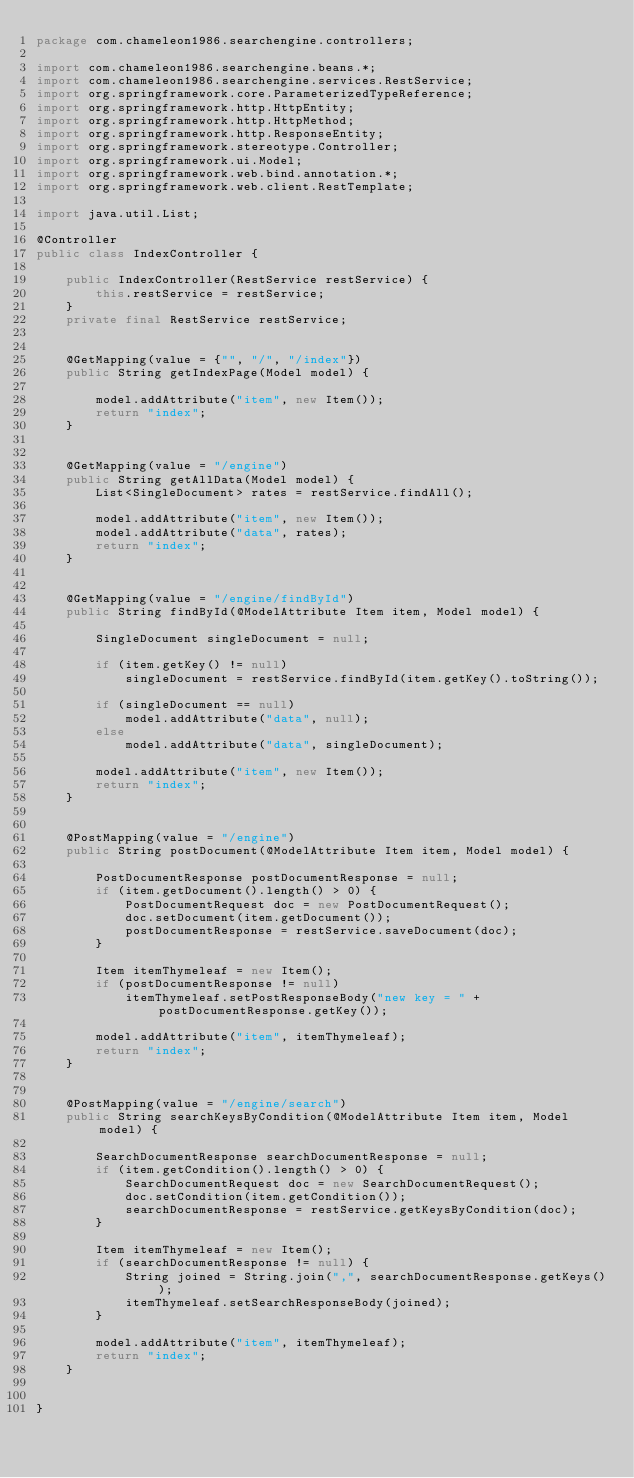<code> <loc_0><loc_0><loc_500><loc_500><_Java_>package com.chameleon1986.searchengine.controllers;

import com.chameleon1986.searchengine.beans.*;
import com.chameleon1986.searchengine.services.RestService;
import org.springframework.core.ParameterizedTypeReference;
import org.springframework.http.HttpEntity;
import org.springframework.http.HttpMethod;
import org.springframework.http.ResponseEntity;
import org.springframework.stereotype.Controller;
import org.springframework.ui.Model;
import org.springframework.web.bind.annotation.*;
import org.springframework.web.client.RestTemplate;

import java.util.List;

@Controller
public class IndexController {

    public IndexController(RestService restService) {
        this.restService = restService;
    }
    private final RestService restService;


    @GetMapping(value = {"", "/", "/index"})
    public String getIndexPage(Model model) {

        model.addAttribute("item", new Item());
        return "index";
    }


    @GetMapping(value = "/engine")
    public String getAllData(Model model) {
        List<SingleDocument> rates = restService.findAll();

        model.addAttribute("item", new Item());
        model.addAttribute("data", rates);
        return "index";
    }


    @GetMapping(value = "/engine/findById")
    public String findById(@ModelAttribute Item item, Model model) {

        SingleDocument singleDocument = null;

        if (item.getKey() != null)
            singleDocument = restService.findById(item.getKey().toString());

        if (singleDocument == null)
            model.addAttribute("data", null);
        else
            model.addAttribute("data", singleDocument);

        model.addAttribute("item", new Item());
        return "index";
    }


    @PostMapping(value = "/engine")
    public String postDocument(@ModelAttribute Item item, Model model) {

        PostDocumentResponse postDocumentResponse = null;
        if (item.getDocument().length() > 0) {
            PostDocumentRequest doc = new PostDocumentRequest();
            doc.setDocument(item.getDocument());
            postDocumentResponse = restService.saveDocument(doc);
        }

        Item itemThymeleaf = new Item();
        if (postDocumentResponse != null)
            itemThymeleaf.setPostResponseBody("new key = " + postDocumentResponse.getKey());

        model.addAttribute("item", itemThymeleaf);
        return "index";
    }


    @PostMapping(value = "/engine/search")
    public String searchKeysByCondition(@ModelAttribute Item item, Model model) {

        SearchDocumentResponse searchDocumentResponse = null;
        if (item.getCondition().length() > 0) {
            SearchDocumentRequest doc = new SearchDocumentRequest();
            doc.setCondition(item.getCondition());
            searchDocumentResponse = restService.getKeysByCondition(doc);
        }

        Item itemThymeleaf = new Item();
        if (searchDocumentResponse != null) {
            String joined = String.join(",", searchDocumentResponse.getKeys());
            itemThymeleaf.setSearchResponseBody(joined);
        }

        model.addAttribute("item", itemThymeleaf);
        return "index";
    }


}
</code> 